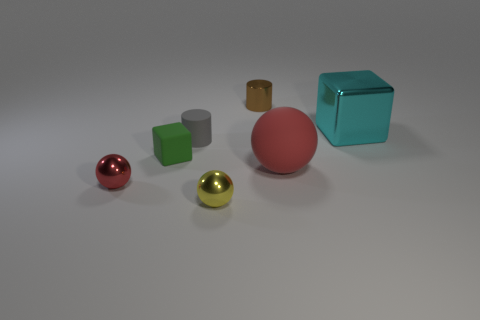Can you tell me which objects are closest to the camera? Certainly. The closest objects to the camera appear to be the shiny red sphere and the green cube. Their larger apparent sizes and clearer details compared to the others suggest they are positioned nearer to the foreground of the image. 